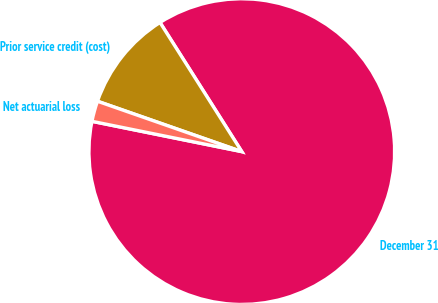Convert chart to OTSL. <chart><loc_0><loc_0><loc_500><loc_500><pie_chart><fcel>December 31<fcel>Prior service credit (cost)<fcel>Net actuarial loss<nl><fcel>87.16%<fcel>10.67%<fcel>2.17%<nl></chart> 